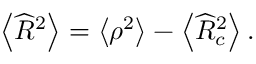Convert formula to latex. <formula><loc_0><loc_0><loc_500><loc_500>\left \langle \widehat { R } ^ { 2 } \right \rangle = \left \langle \rho ^ { 2 } \right \rangle - \left \langle \widehat { R } _ { c } ^ { 2 } \right \rangle .</formula> 